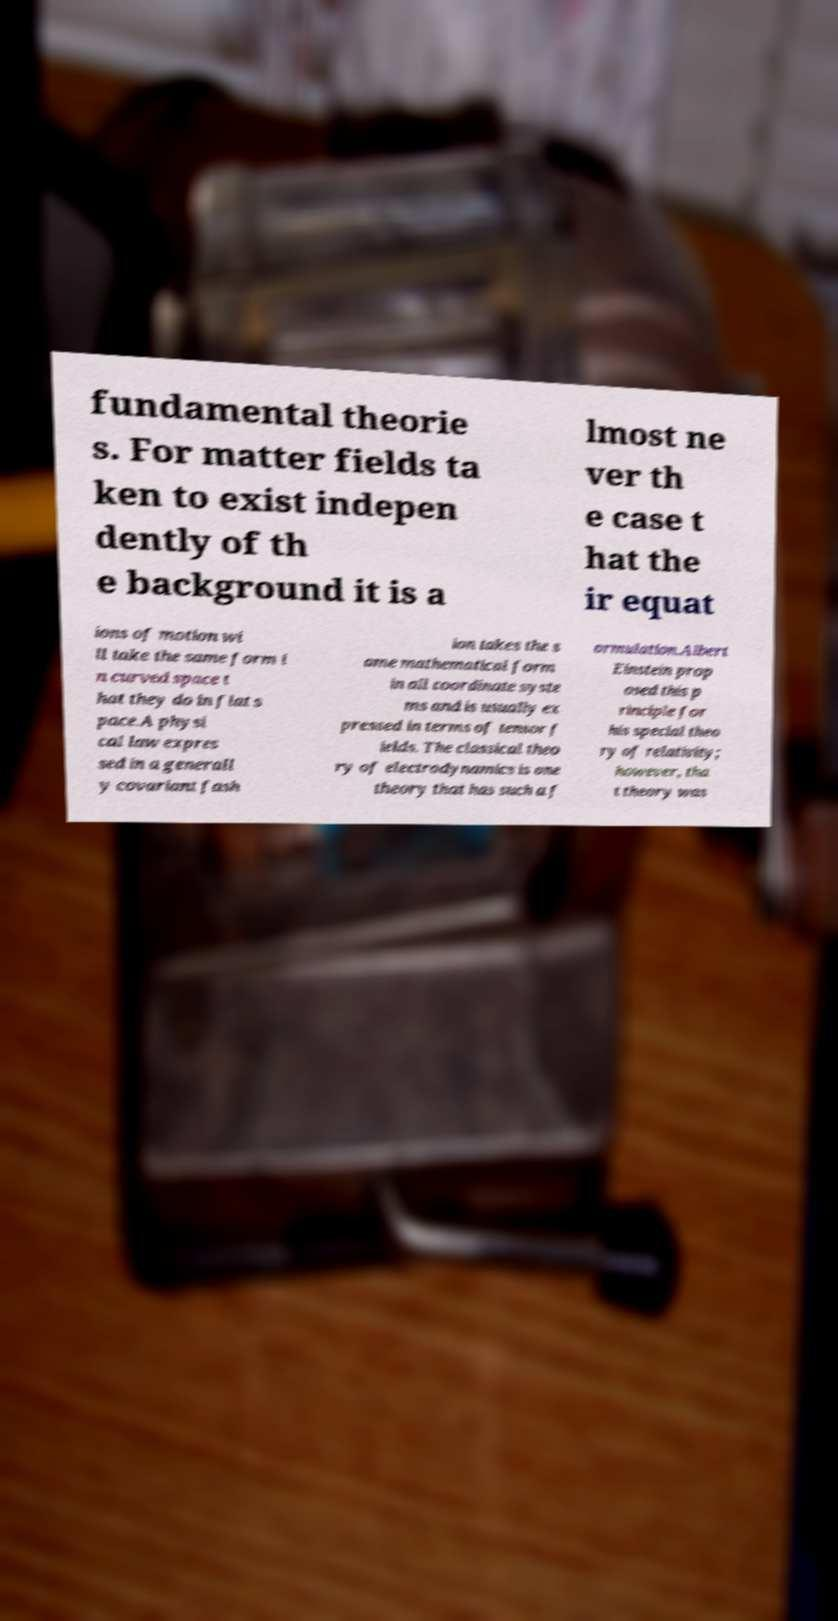Please identify and transcribe the text found in this image. fundamental theorie s. For matter fields ta ken to exist indepen dently of th e background it is a lmost ne ver th e case t hat the ir equat ions of motion wi ll take the same form i n curved space t hat they do in flat s pace.A physi cal law expres sed in a generall y covariant fash ion takes the s ame mathematical form in all coordinate syste ms and is usually ex pressed in terms of tensor f ields. The classical theo ry of electrodynamics is one theory that has such a f ormulation.Albert Einstein prop osed this p rinciple for his special theo ry of relativity; however, tha t theory was 